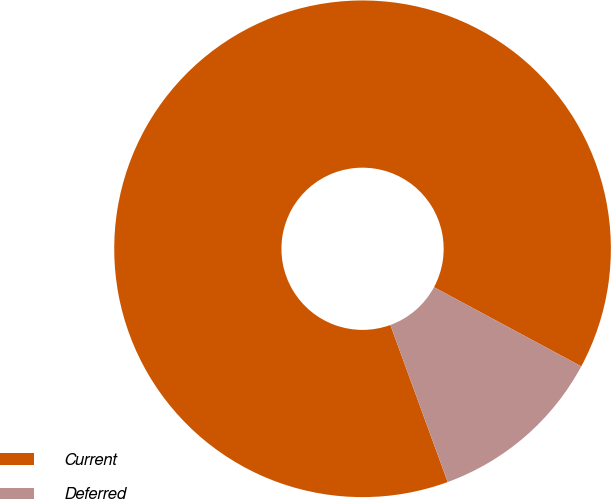Convert chart. <chart><loc_0><loc_0><loc_500><loc_500><pie_chart><fcel>Current<fcel>Deferred<nl><fcel>88.42%<fcel>11.58%<nl></chart> 